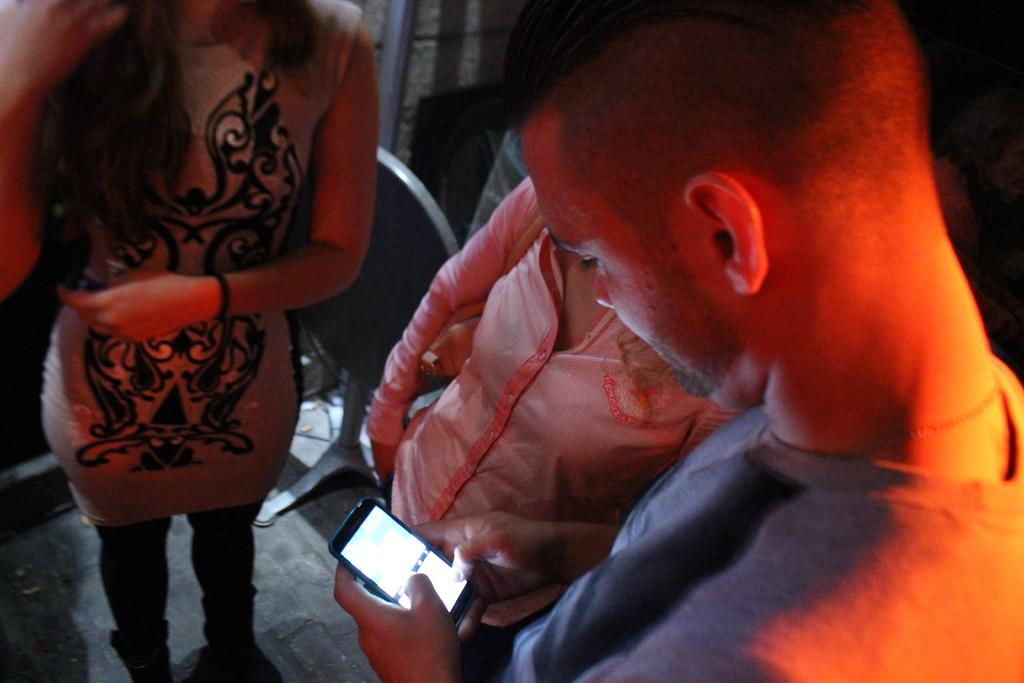What is the man in the image doing? The man is holding a mobile and looking at it. Who else is present in the image besides the man? There are two women standing in the image. Where are the women located in the image? The women are on the floor. What can be seen in the background of the image? There is a chair and a wall in the background of the image. What type of flag is the grandfather holding in the image? There is no grandfather or flag present in the image. Who is the owner of the mobile that the man is holding in the image? The facts provided do not mention the ownership of the mobile, so it cannot be determined from the image. 